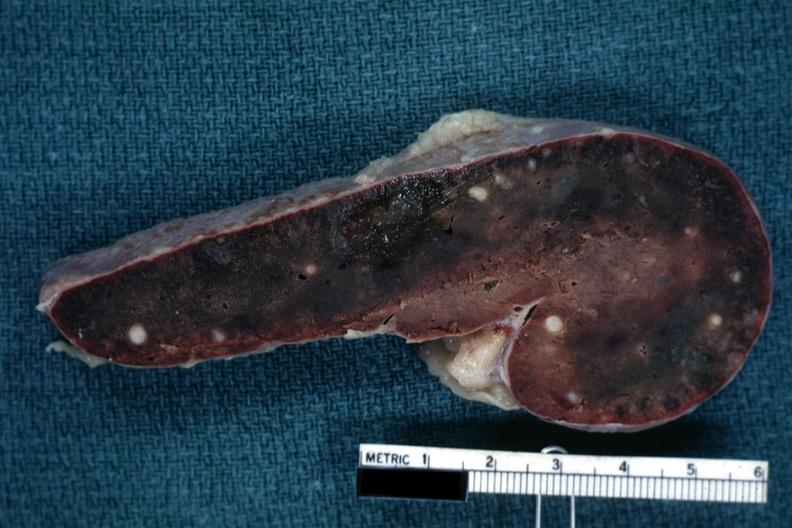does eye show fixed tissue cut surface congested parenchyma with obvious granulomas?
Answer the question using a single word or phrase. No 